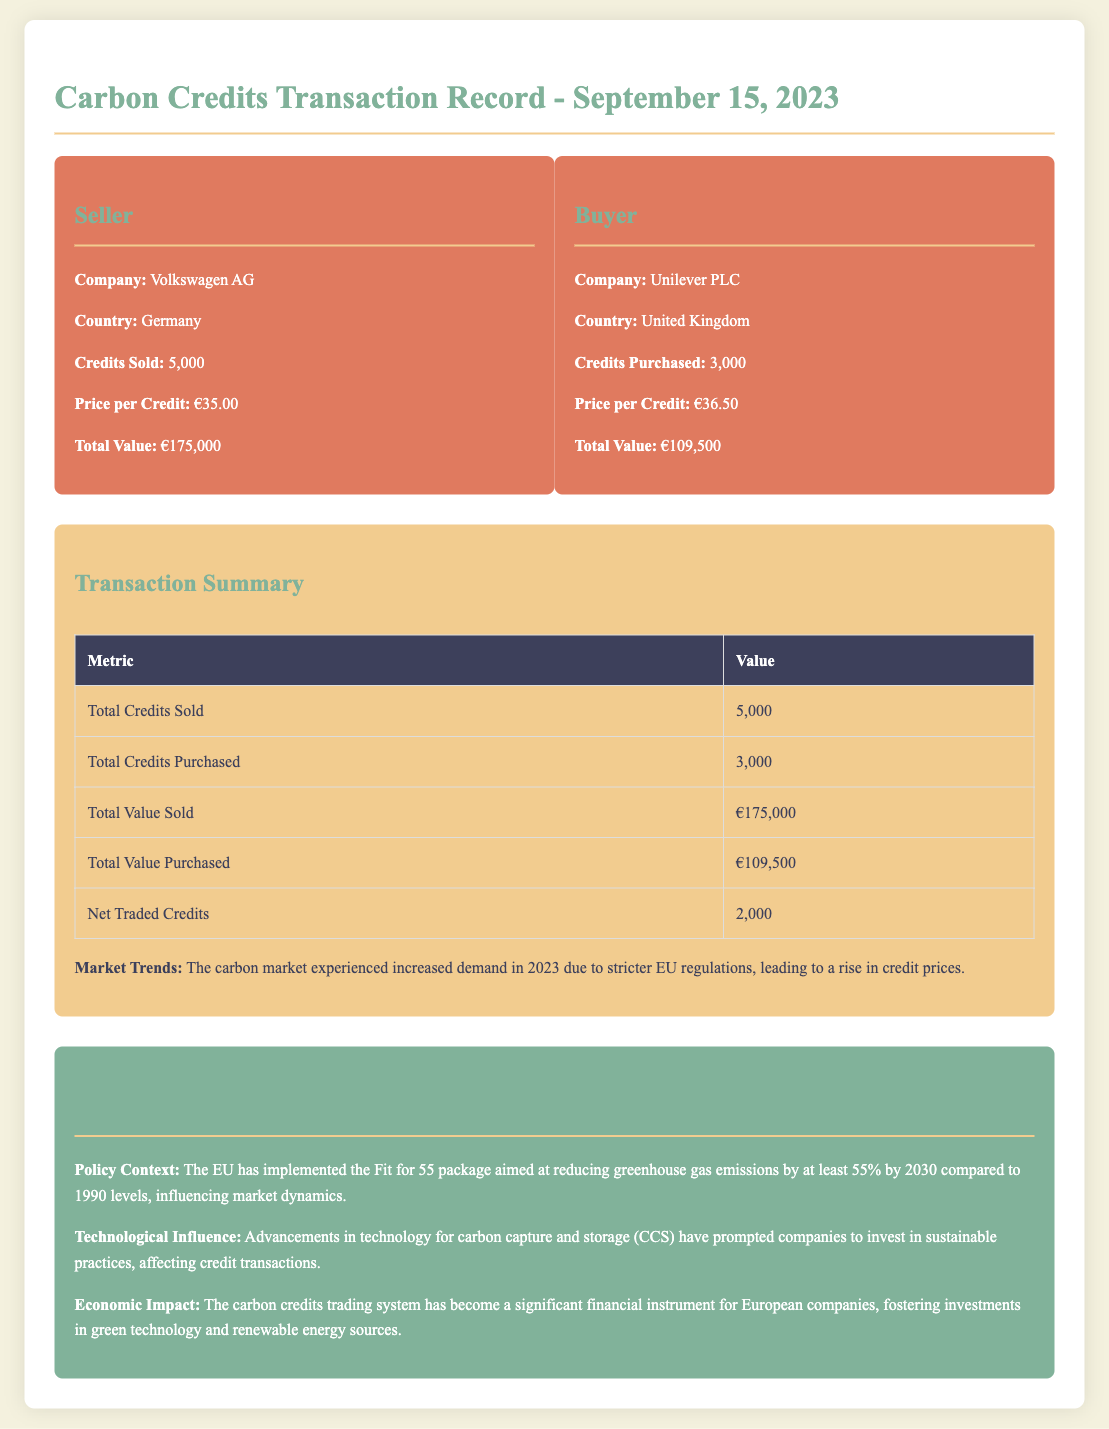What is the date of the transaction? The date of the transaction is explicitly stated at the top of the document.
Answer: September 15, 2023 Who sold the carbon credits? The document identifies the seller in the transaction details section.
Answer: Volkswagen AG How many credits were purchased? The buyer's credits purchased are detailed in the transaction card for the buyer.
Answer: 3,000 What was the price per credit for the seller? The pricing information for the seller is provided in the transaction card under price per credit.
Answer: €35.00 What is the total value of credits sold? The total value of credits sold is calculated based on the number of credits sold and their price per credit.
Answer: €175,000 What is the net traded credits? The net traded credits are summarized in the transaction summary table.
Answer: 2,000 What policy context influences the carbon market? The document describes the relevant policy context affecting the carbon market under key aspects.
Answer: Fit for 55 package What economic impact does the carbon trading system have? The document discusses the economic impact in the key aspects section.
Answer: Significant financial instrument How many credits did Unilever purchase? The transaction card for the buyer specifies the number of credits purchased.
Answer: 3,000 